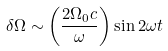<formula> <loc_0><loc_0><loc_500><loc_500>\delta \Omega \sim \left ( \frac { 2 \Omega _ { 0 } c } \omega \right ) \sin 2 \omega t</formula> 